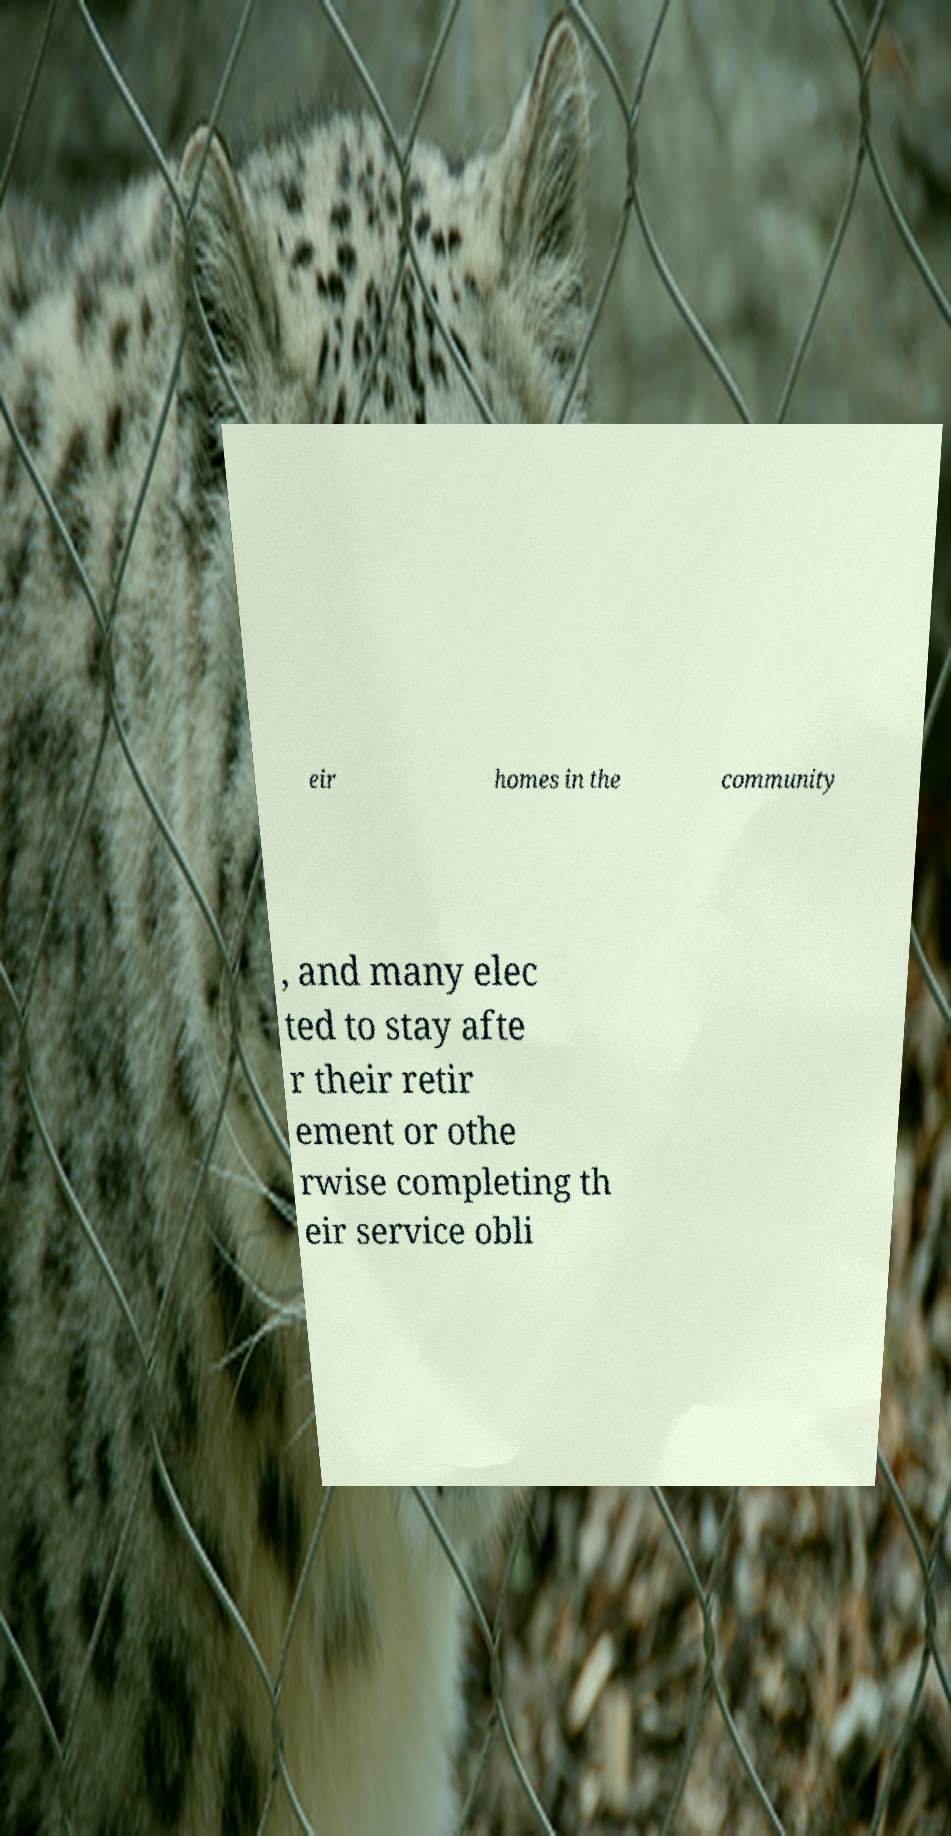Could you extract and type out the text from this image? eir homes in the community , and many elec ted to stay afte r their retir ement or othe rwise completing th eir service obli 